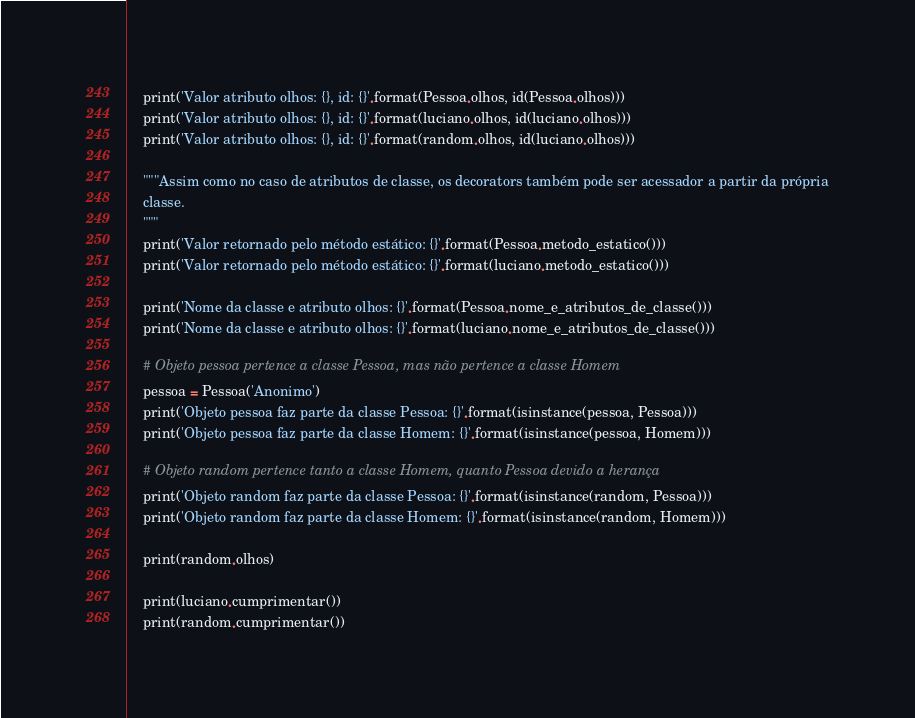<code> <loc_0><loc_0><loc_500><loc_500><_Python_>    print('Valor atributo olhos: {}, id: {}'.format(Pessoa.olhos, id(Pessoa.olhos)))
    print('Valor atributo olhos: {}, id: {}'.format(luciano.olhos, id(luciano.olhos)))
    print('Valor atributo olhos: {}, id: {}'.format(random.olhos, id(luciano.olhos)))

    """Assim como no caso de atributos de classe, os decorators também pode ser acessador a partir da própria
    classe.
    """
    print('Valor retornado pelo método estático: {}'.format(Pessoa.metodo_estatico()))
    print('Valor retornado pelo método estático: {}'.format(luciano.metodo_estatico()))

    print('Nome da classe e atributo olhos: {}'.format(Pessoa.nome_e_atributos_de_classe()))
    print('Nome da classe e atributo olhos: {}'.format(luciano.nome_e_atributos_de_classe()))

    # Objeto pessoa pertence a classe Pessoa, mas não pertence a classe Homem
    pessoa = Pessoa('Anonimo')
    print('Objeto pessoa faz parte da classe Pessoa: {}'.format(isinstance(pessoa, Pessoa)))
    print('Objeto pessoa faz parte da classe Homem: {}'.format(isinstance(pessoa, Homem)))

    # Objeto random pertence tanto a classe Homem, quanto Pessoa devido a herança
    print('Objeto random faz parte da classe Pessoa: {}'.format(isinstance(random, Pessoa)))
    print('Objeto random faz parte da classe Homem: {}'.format(isinstance(random, Homem)))

    print(random.olhos)

    print(luciano.cumprimentar())
    print(random.cumprimentar())
</code> 